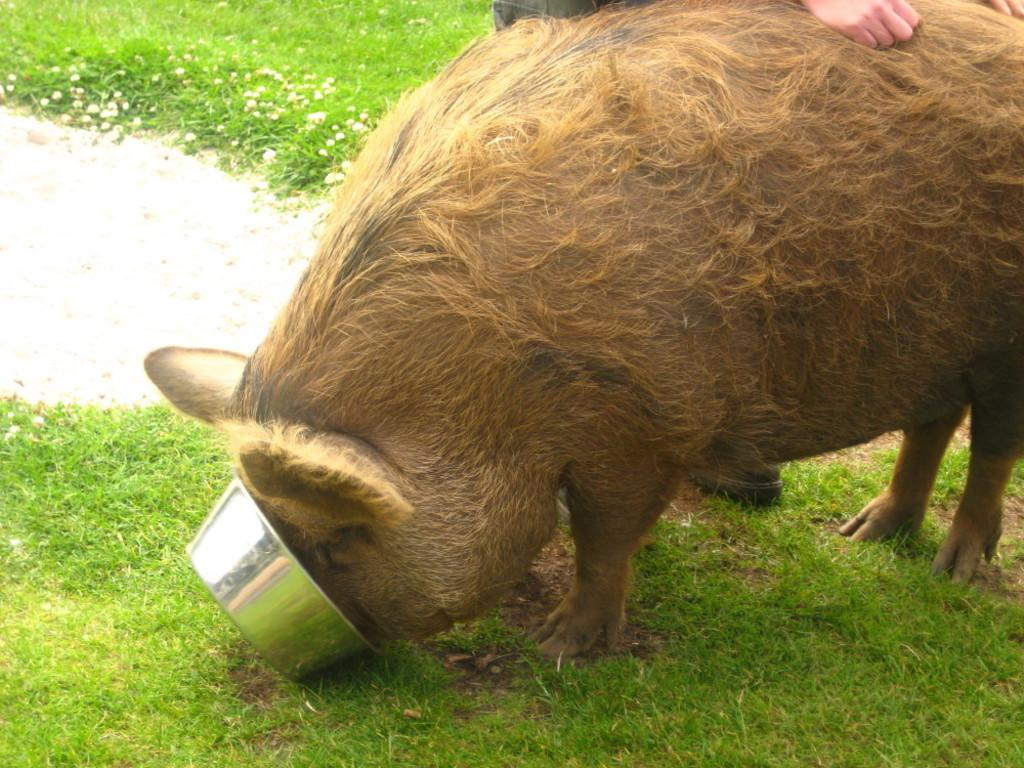What is the main subject in the center of the image? There is an animal in the center of the image. What type of terrain is visible in the image? There is grass on the ground in the image. Can you describe the person in the background of the image? There is a person standing in the background of the image. What is the person doing in relation to the animal? The person is touching the animal. What type of attraction is the person seeking approval for in the image? There is no indication in the image that the person is seeking approval for any attraction. 